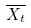<formula> <loc_0><loc_0><loc_500><loc_500>\overline { X _ { t } }</formula> 